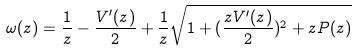Convert formula to latex. <formula><loc_0><loc_0><loc_500><loc_500>\omega ( z ) = \frac { 1 } { z } - \frac { V ^ { \prime } ( z ) } { 2 } + \frac { 1 } { z } \sqrt { 1 + ( \frac { z V ^ { \prime } ( z ) } { 2 } ) ^ { 2 } + z P ( z ) }</formula> 